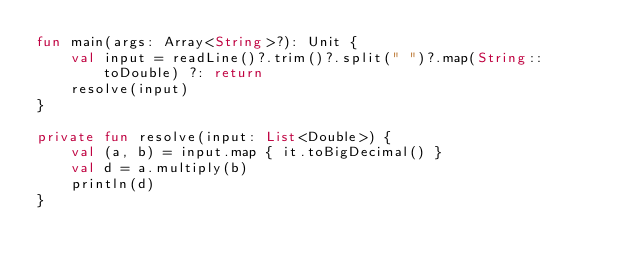Convert code to text. <code><loc_0><loc_0><loc_500><loc_500><_Kotlin_>fun main(args: Array<String>?): Unit {
    val input = readLine()?.trim()?.split(" ")?.map(String::toDouble) ?: return
    resolve(input)
}

private fun resolve(input: List<Double>) {
    val (a, b) = input.map { it.toBigDecimal() }
    val d = a.multiply(b)
    println(d)
}
</code> 